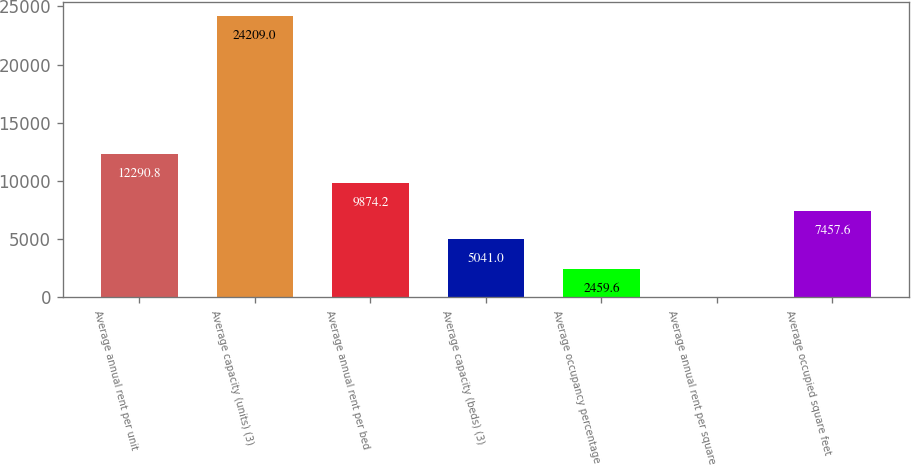Convert chart to OTSL. <chart><loc_0><loc_0><loc_500><loc_500><bar_chart><fcel>Average annual rent per unit<fcel>Average capacity (units) (3)<fcel>Average annual rent per bed<fcel>Average capacity (beds) (3)<fcel>Average occupancy percentage<fcel>Average annual rent per square<fcel>Average occupied square feet<nl><fcel>12290.8<fcel>24209<fcel>9874.2<fcel>5041<fcel>2459.6<fcel>43<fcel>7457.6<nl></chart> 